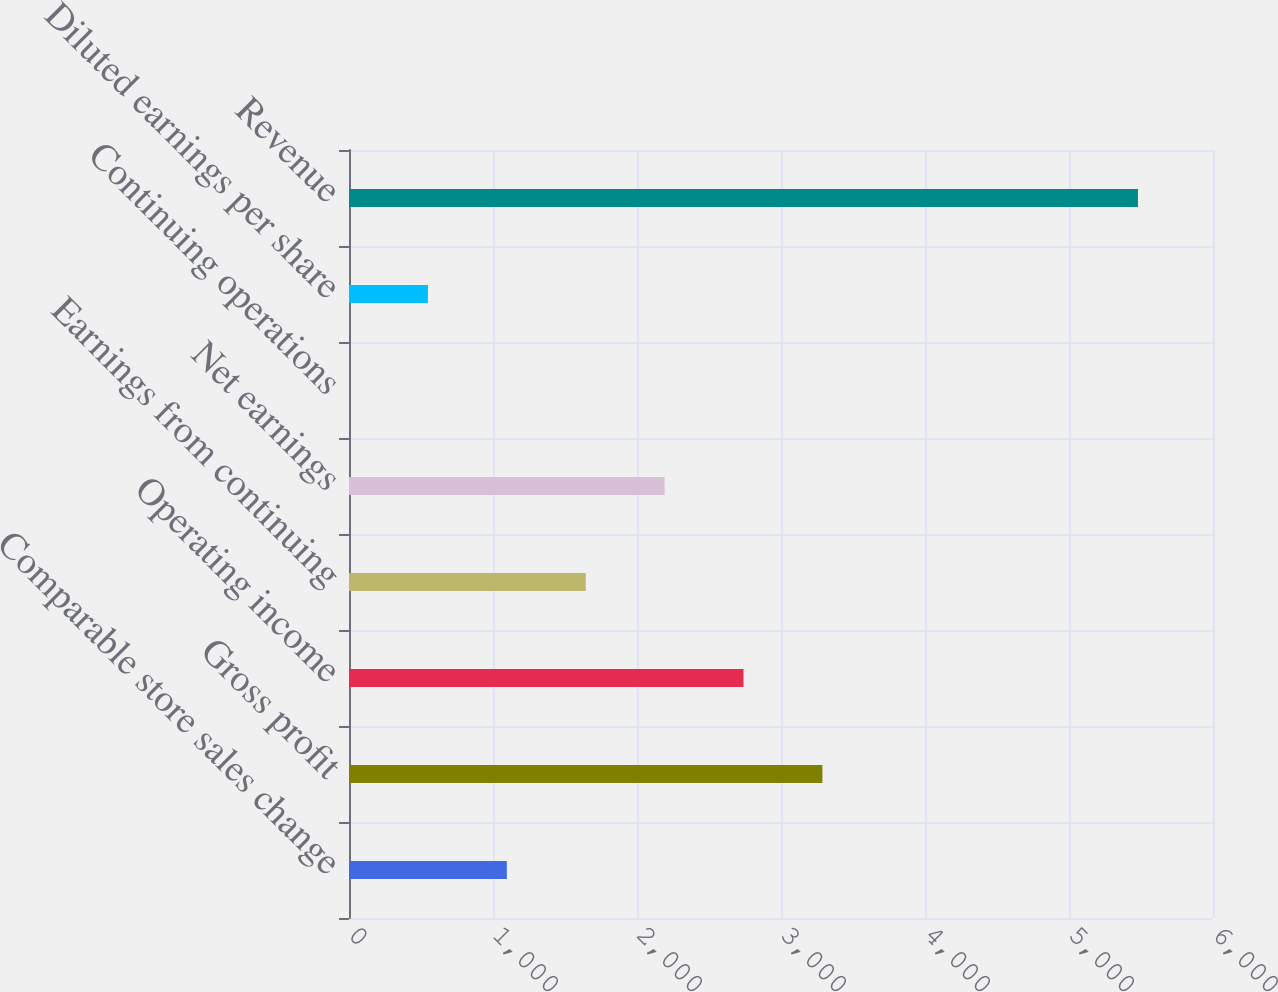Convert chart. <chart><loc_0><loc_0><loc_500><loc_500><bar_chart><fcel>Comparable store sales change<fcel>Gross profit<fcel>Operating income<fcel>Earnings from continuing<fcel>Net earnings<fcel>Continuing operations<fcel>Diluted earnings per share<fcel>Revenue<nl><fcel>1096.08<fcel>3287.56<fcel>2739.69<fcel>1643.95<fcel>2191.82<fcel>0.34<fcel>548.21<fcel>5479<nl></chart> 